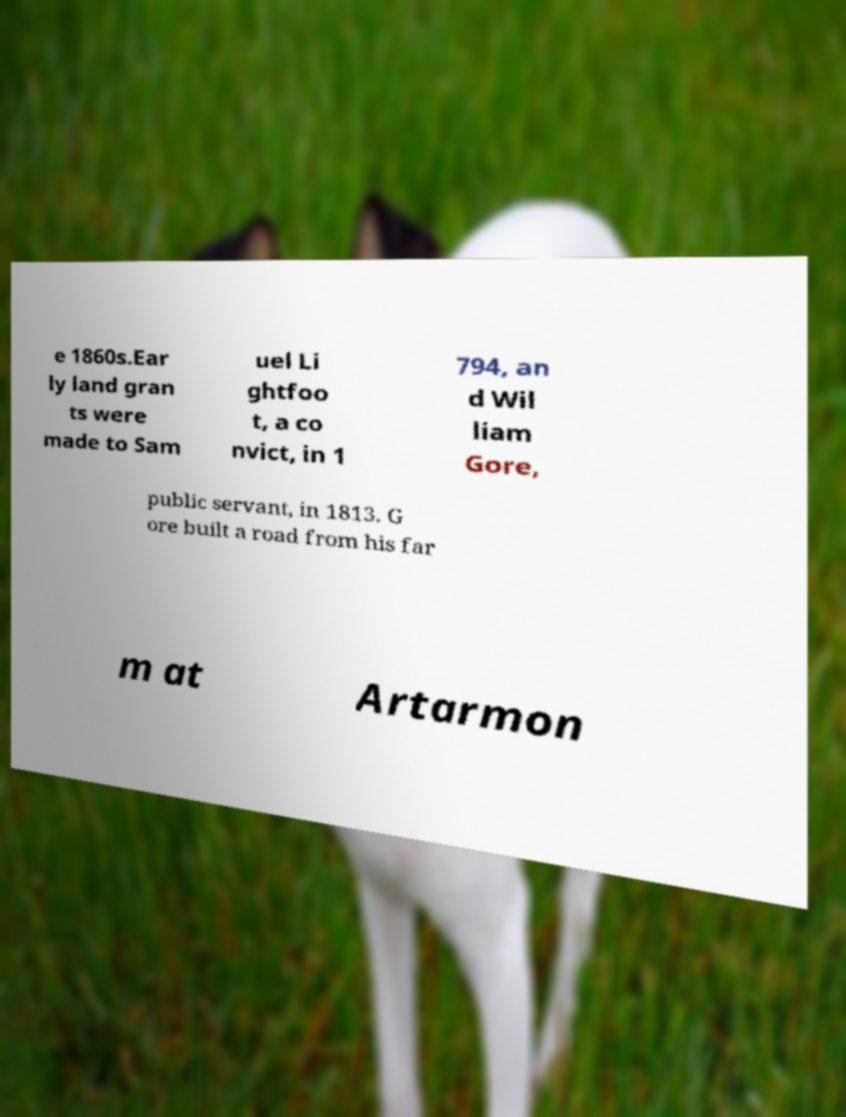Could you extract and type out the text from this image? e 1860s.Ear ly land gran ts were made to Sam uel Li ghtfoo t, a co nvict, in 1 794, an d Wil liam Gore, public servant, in 1813. G ore built a road from his far m at Artarmon 